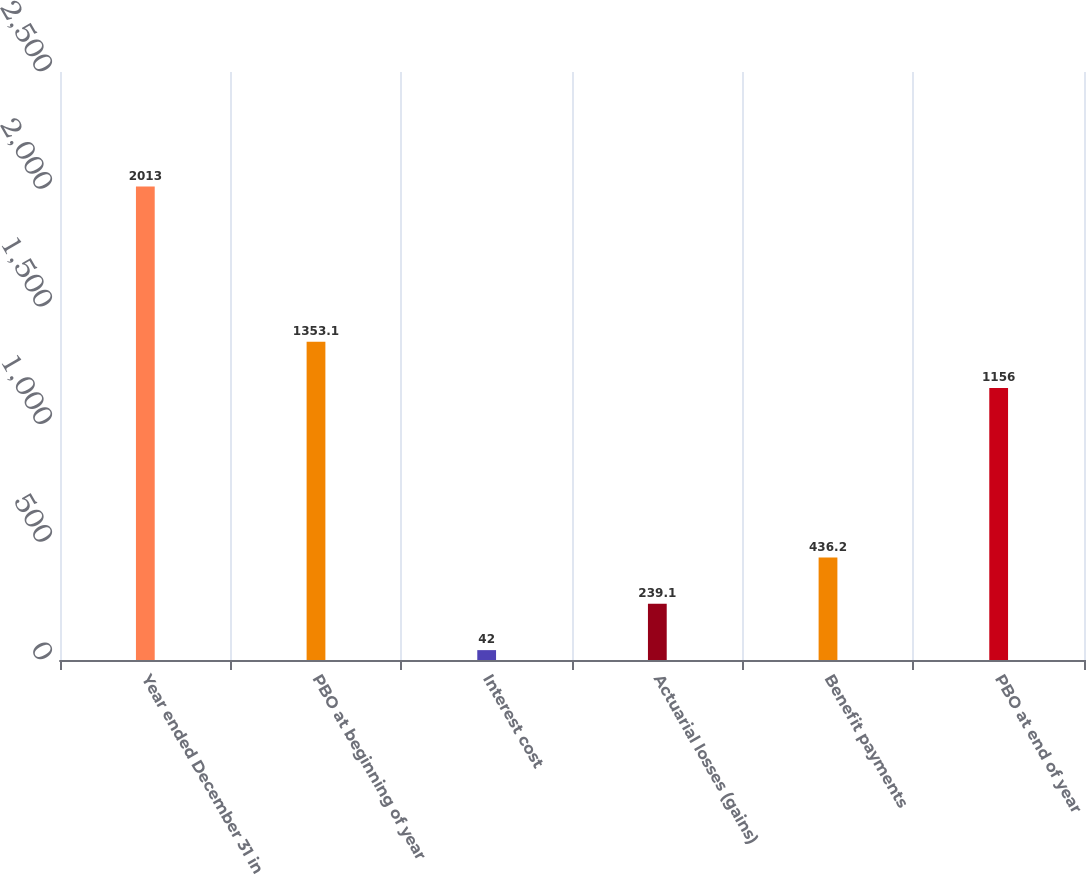<chart> <loc_0><loc_0><loc_500><loc_500><bar_chart><fcel>Year ended December 31 in<fcel>PBO at beginning of year<fcel>Interest cost<fcel>Actuarial losses (gains)<fcel>Benefit payments<fcel>PBO at end of year<nl><fcel>2013<fcel>1353.1<fcel>42<fcel>239.1<fcel>436.2<fcel>1156<nl></chart> 